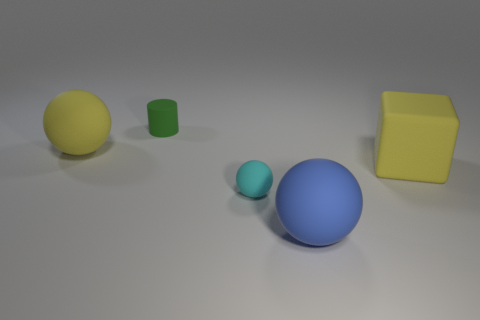Add 2 rubber balls. How many objects exist? 7 Subtract all cubes. How many objects are left? 4 Subtract 0 purple blocks. How many objects are left? 5 Subtract all matte blocks. Subtract all blocks. How many objects are left? 3 Add 5 yellow rubber balls. How many yellow rubber balls are left? 6 Add 5 tiny red shiny balls. How many tiny red shiny balls exist? 5 